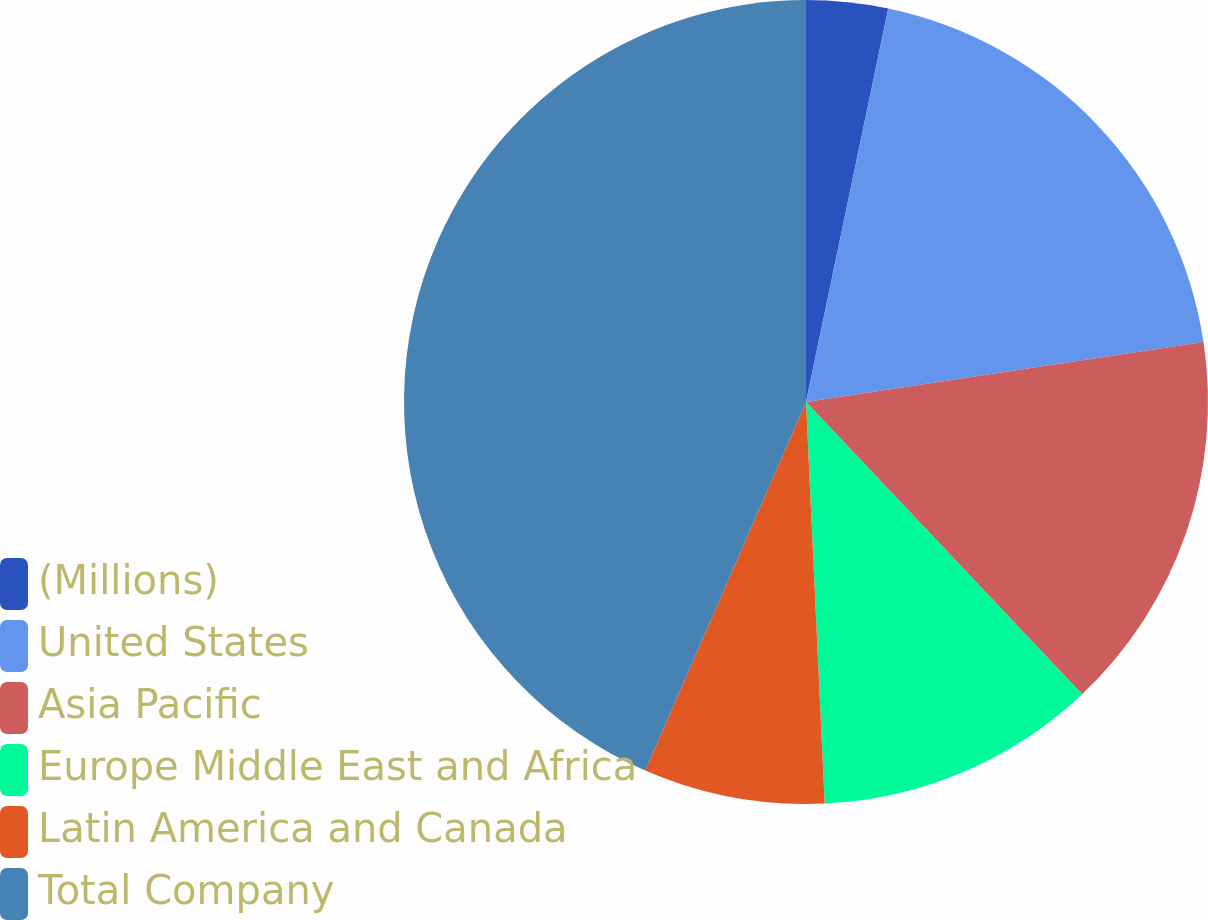Convert chart to OTSL. <chart><loc_0><loc_0><loc_500><loc_500><pie_chart><fcel>(Millions)<fcel>United States<fcel>Asia Pacific<fcel>Europe Middle East and Africa<fcel>Latin America and Canada<fcel>Total Company<nl><fcel>3.28%<fcel>19.34%<fcel>15.33%<fcel>11.31%<fcel>7.29%<fcel>43.45%<nl></chart> 